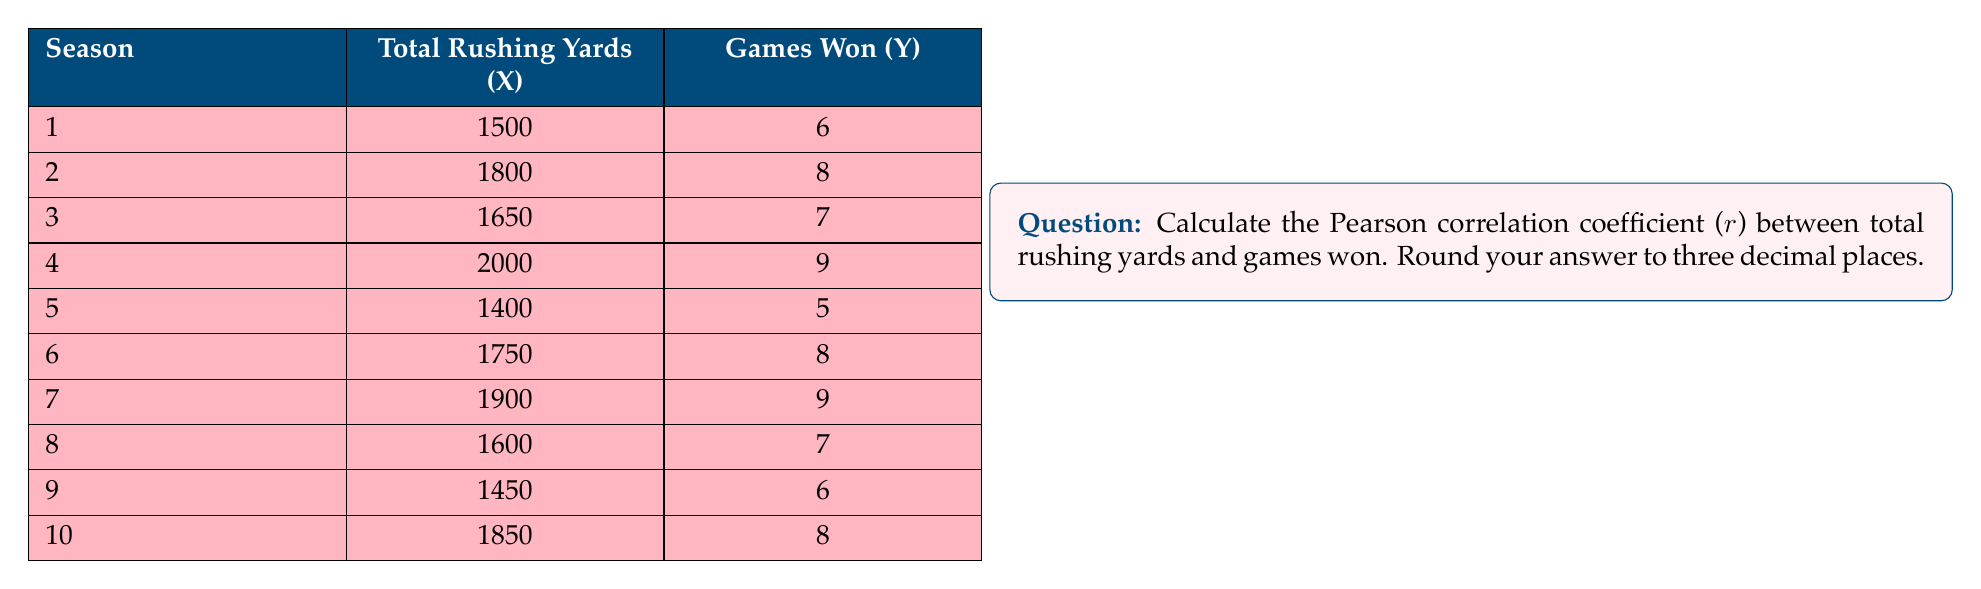Help me with this question. To calculate the Pearson correlation coefficient, we'll use the formula:

$$ r = \frac{\sum_{i=1}^{n} (x_i - \bar{x})(y_i - \bar{y})}{\sqrt{\sum_{i=1}^{n} (x_i - \bar{x})^2 \sum_{i=1}^{n} (y_i - \bar{y})^2}} $$

Where:
$x_i$ = individual X values
$y_i$ = individual Y values
$\bar{x}$ = mean of X values
$\bar{y}$ = mean of Y values
$n$ = number of pairs of data

Step 1: Calculate the means
$\bar{x} = \frac{1500 + 1800 + 1650 + 2000 + 1400 + 1750 + 1900 + 1600 + 1450 + 1850}{10} = 1690$
$\bar{y} = \frac{6 + 8 + 7 + 9 + 5 + 8 + 9 + 7 + 6 + 8}{10} = 7.3$

Step 2: Calculate $(x_i - \bar{x})$, $(y_i - \bar{y})$, $(x_i - \bar{x})^2$, $(y_i - \bar{y})^2$, and $(x_i - \bar{x})(y_i - \bar{y})$ for each pair

Step 3: Sum up the values from Step 2
$\sum (x_i - \bar{x})(y_i - \bar{y}) = 437,000$
$\sum (x_i - \bar{x})^2 = 505,000$
$\sum (y_i - \bar{y})^2 = 16.1$

Step 4: Apply the formula
$$ r = \frac{437,000}{\sqrt{505,000 \times 16.1}} = \frac{437,000}{2,851.85} = 0.9714 $$

Step 5: Round to three decimal places
$r = 0.971$
Answer: The Pearson correlation coefficient (r) between total rushing yards and games won is 0.971. 